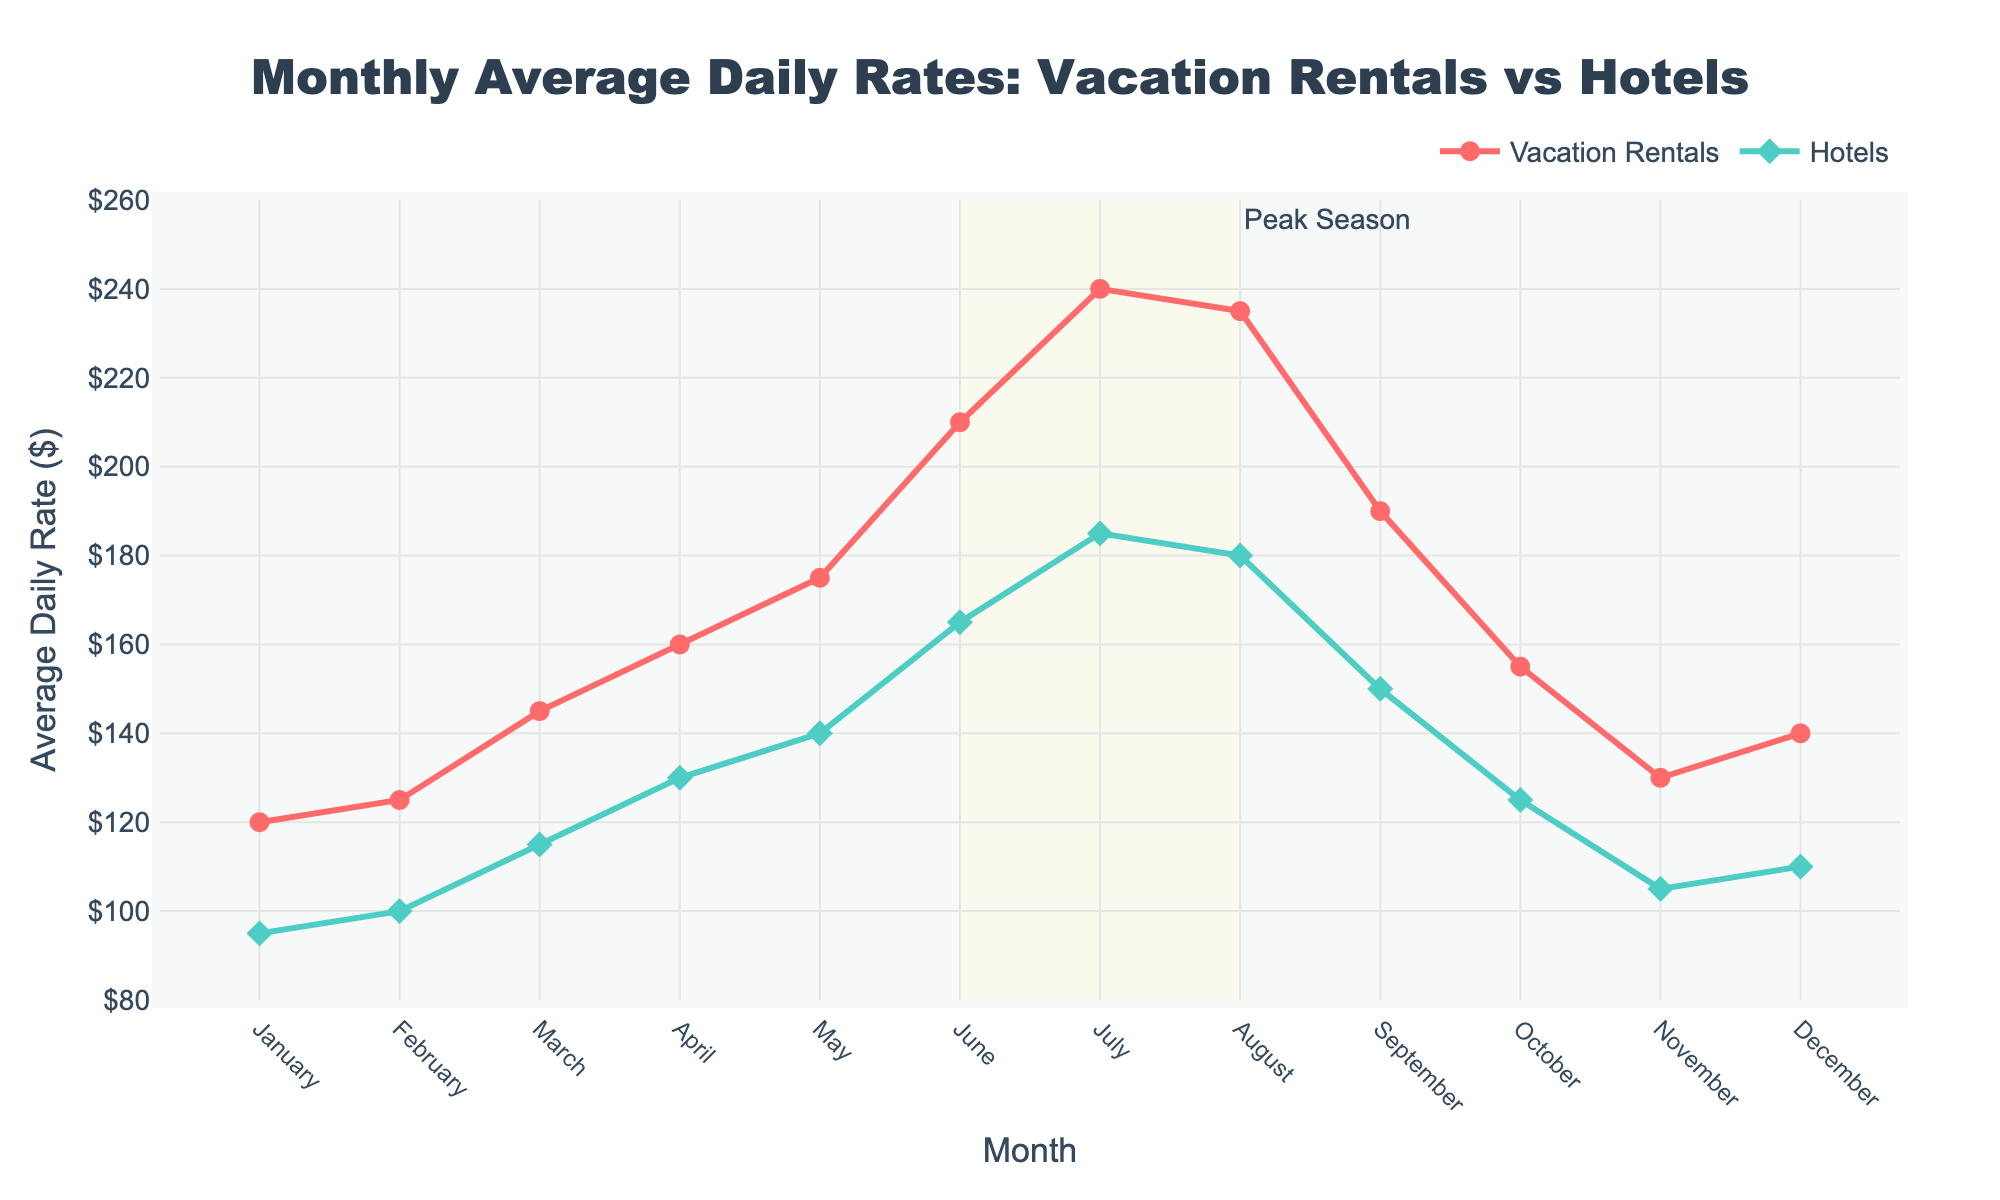what are the average daily rates for vacation rentals and hotels in July? To find the average daily rates for vacation rentals and hotels in July, look at the data points for July on the graph. The rate for vacation rentals in July is $240, and for hotels, it is $185.
Answer: $240, $185 how much higher is the average daily rate for vacation rentals compared to hotels in August? To determine how much higher the average rate is for vacation rentals compared to hotels in August, subtract the hotel rate from the vacation rental rate in August: $235 - $180 = $55.
Answer: $55 during which month did vacation rentals have the smallest difference from hotels? To find the month with the smallest difference, compare the differences in rates for each month. The smallest difference is for January: $120 (vacation rentals) - $95 (hotels) = $25.
Answer: January what's the trend of average daily rates for vacation rentals between March and June? To identify the trend between March and June, observe the line for vacation rentals from March to June. The rate increases from $145 in March to $210 in June.
Answer: Increasing which month has the highest average daily rate for hotels, and what is the value? Identify the highest point in the hotel rate line, which is in July, with a value of $185.
Answer: July, $185 what's the difference in average daily rates between peak seasons for vacation rentals and hotels? The difference in average daily rates in peak season (June to August) is calculated by averaging the rates for both categories during these months. Vacation rentals: ($210 + $240 + $235) / 3 = $228.33, Hotels: ($165 + $185 + $180) / 3 = $176.67. The difference is $228.33 - $176.67 = $51.66.
Answer: $51.66 are there any months when the average daily rate for vacation rentals is equal to or below the rate for hotels? To find this, compare each month's rates for vacation rentals and hotels. There are no months when the rental rate is equal to or below the hotel rate as rentals are always higher.
Answer: No what's the general relationship between the rates for vacation rentals and hotels over the year? In general, the rates for vacation rentals are consistently higher than those for hotels throughout the year.
Answer: Vacation rentals are higher how do the average daily rates for both vacation rentals and hotels change from January to December? To analyze this, look at the overall trend from January to December. Both rates see an overall increase and then return to similar starting points by December. For rentals: starts at $120, peaks in July, and ends at $140. For hotels: starts at $95, peaks in July, and ends at $110.
Answer: Both increase, peak in summer, then decrease 